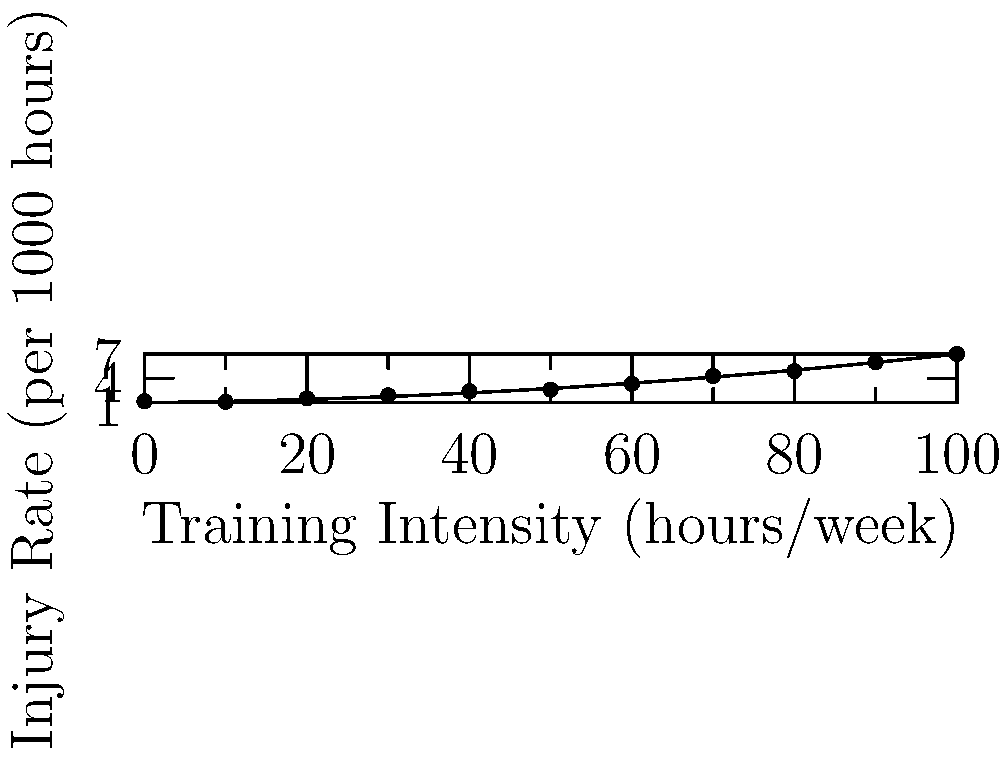The scatter plot shows the relationship between training intensity and injury rates in basketball players. If the best-fit curve is given by the function $f(x) = ax^2 + bx + c$, where $x$ is the training intensity in hours per week and $f(x)$ is the injury rate per 1000 hours, what is the approximate increase in injury rate when training intensity increases from 40 to 60 hours per week? To solve this problem, we need to follow these steps:

1) From the given information, we know that $f(x) = ax^2 + bx + c$, where $a = 0.0005$, $b = 0.01$, and $c = 1$.

2) We need to calculate $f(60) - f(40)$ to find the increase in injury rate.

3) Let's calculate $f(60)$:
   $f(60) = 0.0005(60)^2 + 0.01(60) + 1$
   $= 0.0005(3600) + 0.6 + 1$
   $= 1.8 + 0.6 + 1 = 3.4$

4) Now, let's calculate $f(40)$:
   $f(40) = 0.0005(40)^2 + 0.01(40) + 1$
   $= 0.0005(1600) + 0.4 + 1$
   $= 0.8 + 0.4 + 1 = 2.2$

5) The increase in injury rate is:
   $f(60) - f(40) = 3.4 - 2.2 = 1.2$

Therefore, the injury rate increases by approximately 1.2 per 1000 hours when training intensity increases from 40 to 60 hours per week.
Answer: 1.2 per 1000 hours 